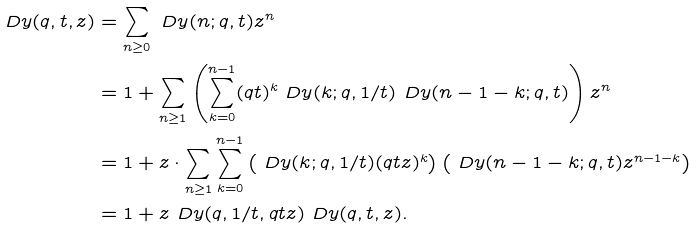<formula> <loc_0><loc_0><loc_500><loc_500>\ D y ( q , t , z ) & = \sum _ { n \geq 0 } \ D y ( n ; q , t ) z ^ { n } \\ & = 1 + \sum _ { n \geq 1 } \left ( \sum _ { k = 0 } ^ { n - 1 } ( q t ) ^ { k } \ D y ( k ; q , 1 / t ) \ D y ( n - 1 - k ; q , t ) \right ) z ^ { n } \\ & = 1 + z \cdot \sum _ { n \geq 1 } \sum _ { k = 0 } ^ { n - 1 } \left ( \ D y ( k ; q , 1 / t ) ( q t z ) ^ { k } \right ) \left ( \ D y ( n - 1 - k ; q , t ) z ^ { n - 1 - k } \right ) \\ & = 1 + z \ D y ( q , 1 / t , q t z ) \ D y ( q , t , z ) .</formula> 